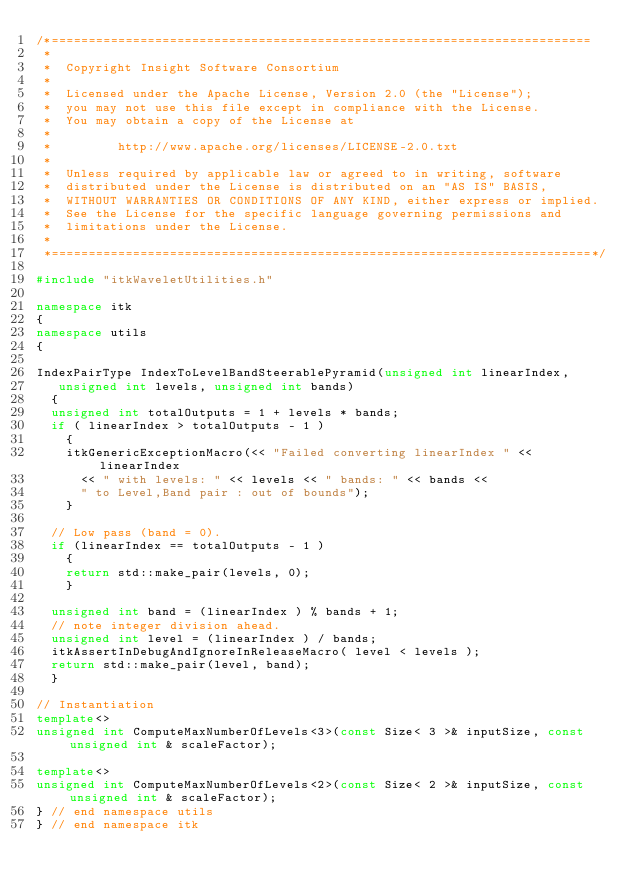<code> <loc_0><loc_0><loc_500><loc_500><_C++_>/*=========================================================================
 *
 *  Copyright Insight Software Consortium
 *
 *  Licensed under the Apache License, Version 2.0 (the "License");
 *  you may not use this file except in compliance with the License.
 *  You may obtain a copy of the License at
 *
 *         http://www.apache.org/licenses/LICENSE-2.0.txt
 *
 *  Unless required by applicable law or agreed to in writing, software
 *  distributed under the License is distributed on an "AS IS" BASIS,
 *  WITHOUT WARRANTIES OR CONDITIONS OF ANY KIND, either express or implied.
 *  See the License for the specific language governing permissions and
 *  limitations under the License.
 *
 *=========================================================================*/

#include "itkWaveletUtilities.h"

namespace itk
{
namespace utils
{

IndexPairType IndexToLevelBandSteerablePyramid(unsigned int linearIndex,
   unsigned int levels, unsigned int bands)
  {
  unsigned int totalOutputs = 1 + levels * bands;
  if ( linearIndex > totalOutputs - 1 )
    {
    itkGenericExceptionMacro(<< "Failed converting linearIndex " << linearIndex
      << " with levels: " << levels << " bands: " << bands <<
      " to Level,Band pair : out of bounds");
    }

  // Low pass (band = 0).
  if (linearIndex == totalOutputs - 1 )
    {
    return std::make_pair(levels, 0);
    }

  unsigned int band = (linearIndex ) % bands + 1;
  // note integer division ahead.
  unsigned int level = (linearIndex ) / bands;
  itkAssertInDebugAndIgnoreInReleaseMacro( level < levels );
  return std::make_pair(level, band);
  }

// Instantiation
template<>
unsigned int ComputeMaxNumberOfLevels<3>(const Size< 3 >& inputSize, const unsigned int & scaleFactor);

template<>
unsigned int ComputeMaxNumberOfLevels<2>(const Size< 2 >& inputSize, const unsigned int & scaleFactor);
} // end namespace utils
} // end namespace itk
</code> 